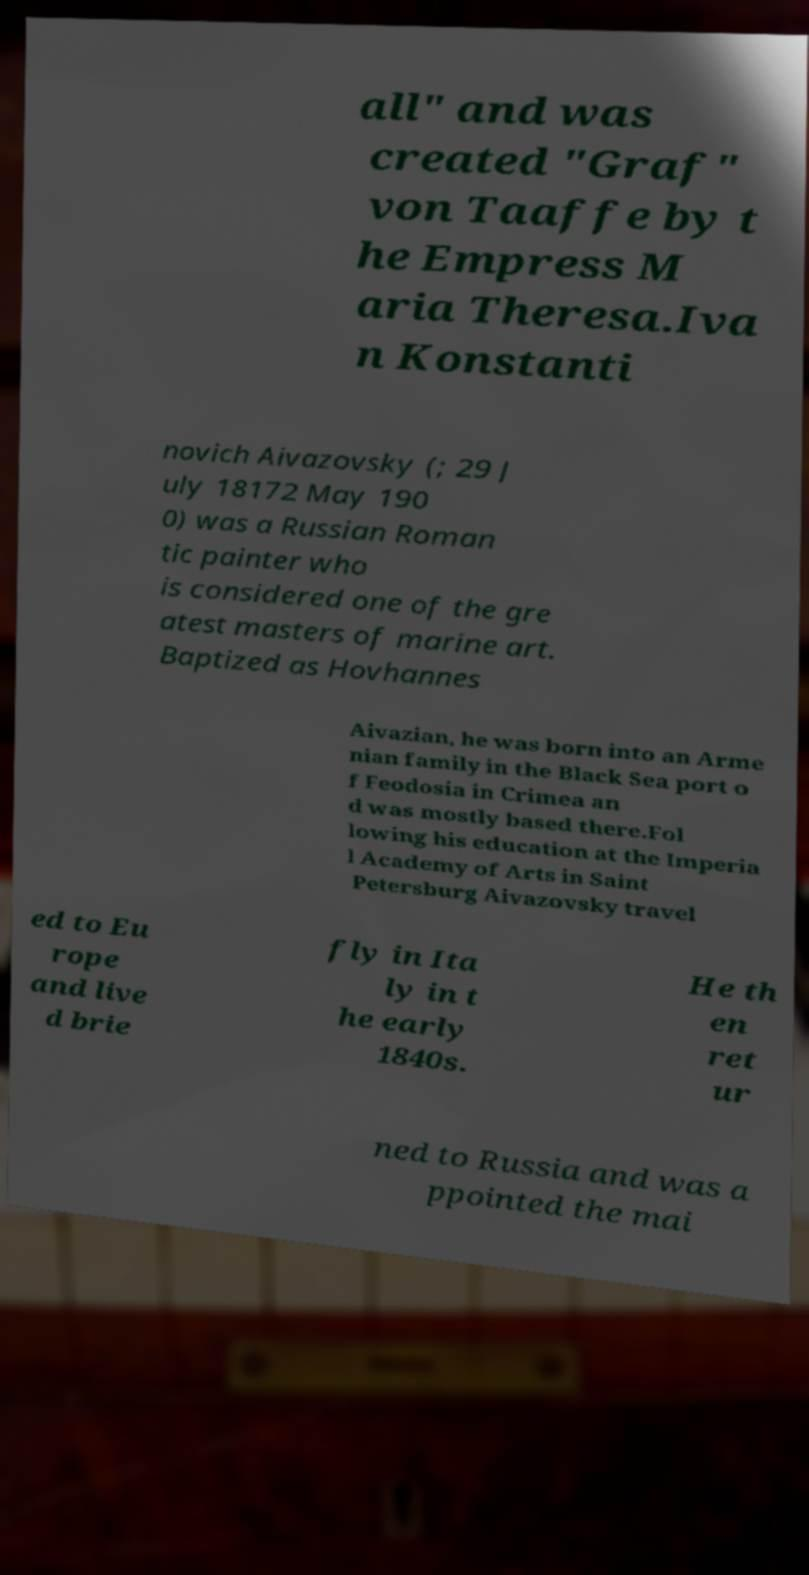Please read and relay the text visible in this image. What does it say? all" and was created "Graf" von Taaffe by t he Empress M aria Theresa.Iva n Konstanti novich Aivazovsky (; 29 J uly 18172 May 190 0) was a Russian Roman tic painter who is considered one of the gre atest masters of marine art. Baptized as Hovhannes Aivazian, he was born into an Arme nian family in the Black Sea port o f Feodosia in Crimea an d was mostly based there.Fol lowing his education at the Imperia l Academy of Arts in Saint Petersburg Aivazovsky travel ed to Eu rope and live d brie fly in Ita ly in t he early 1840s. He th en ret ur ned to Russia and was a ppointed the mai 